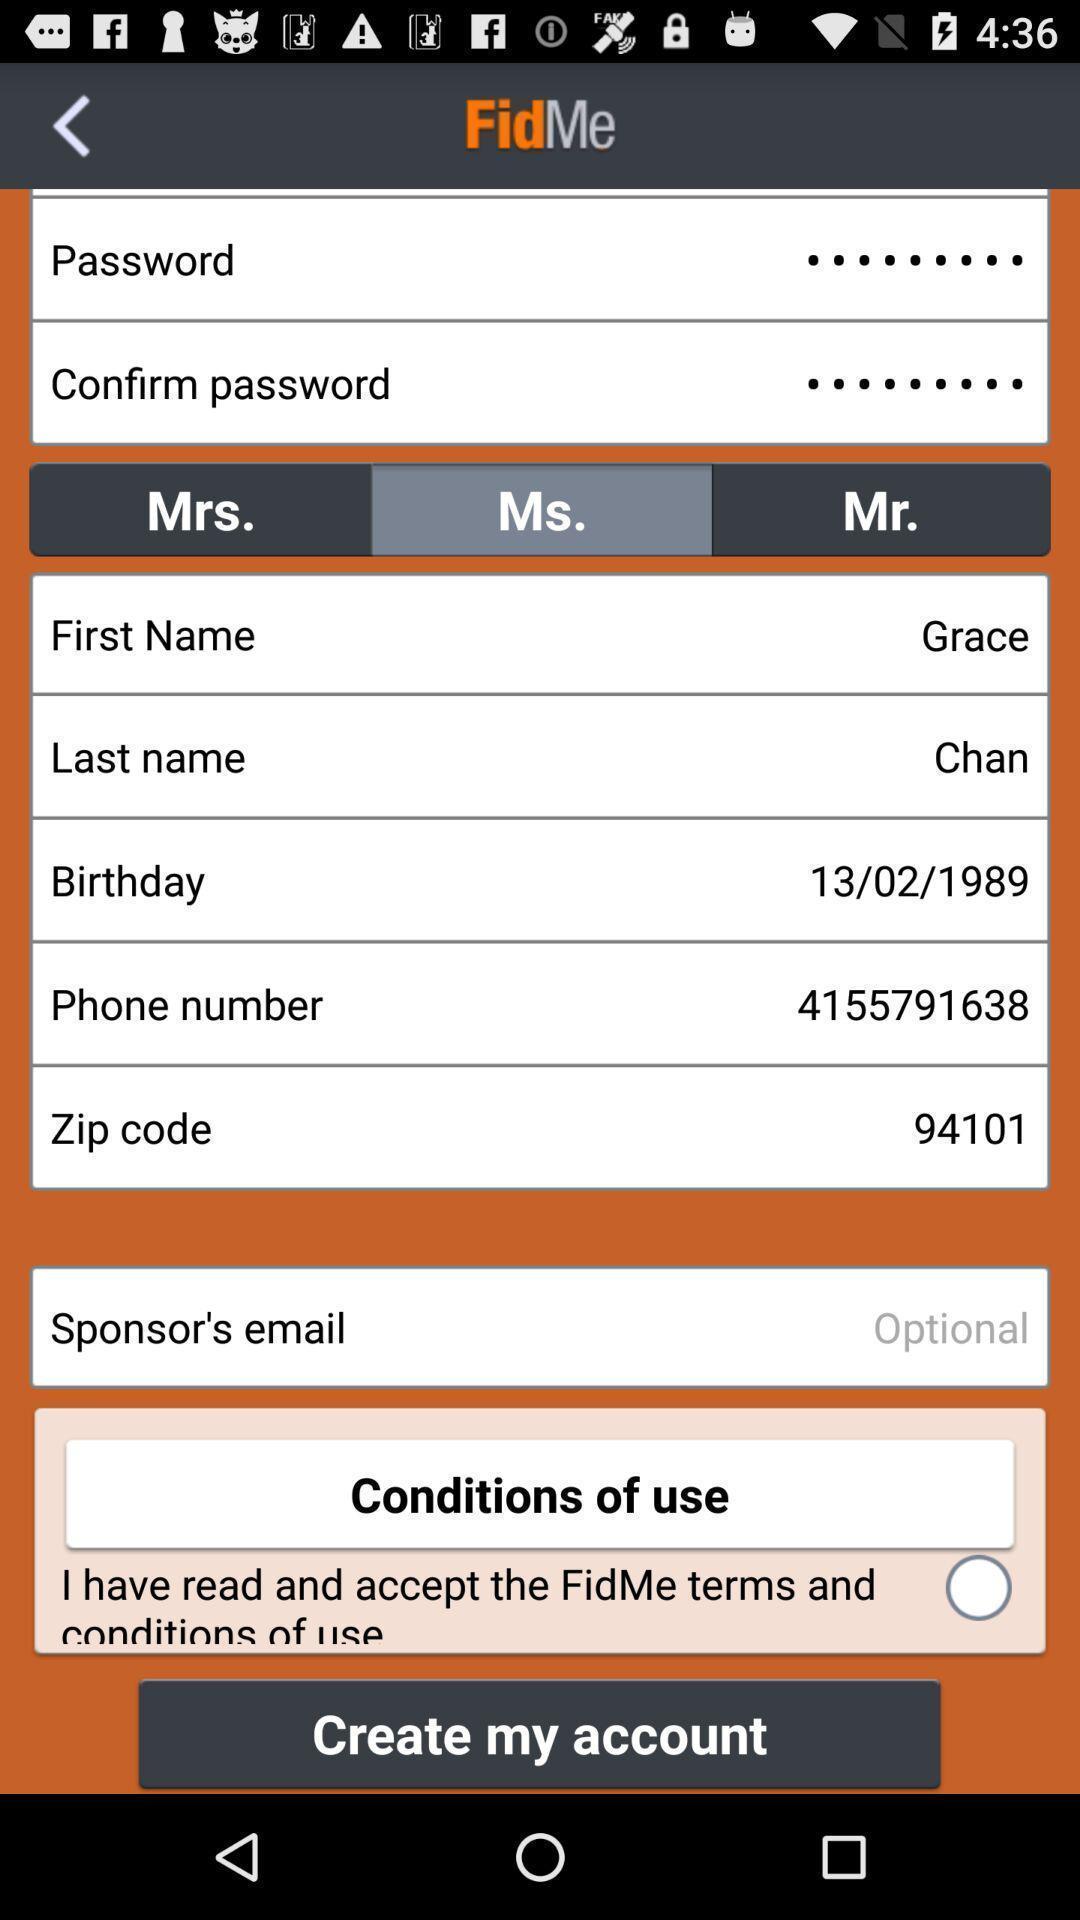Tell me about the visual elements in this screen capture. Screen shows to create an account. 